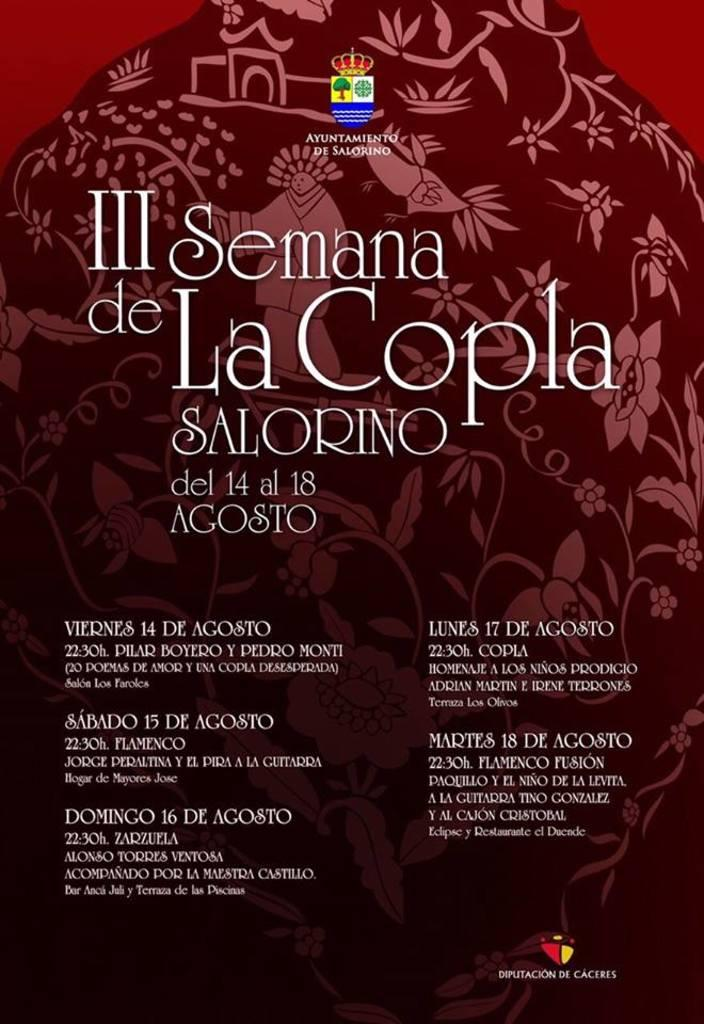Provide a one-sentence caption for the provided image. A Spanish language advertisement for III Semana de La Copla SALORINO including the dates and times of events. 